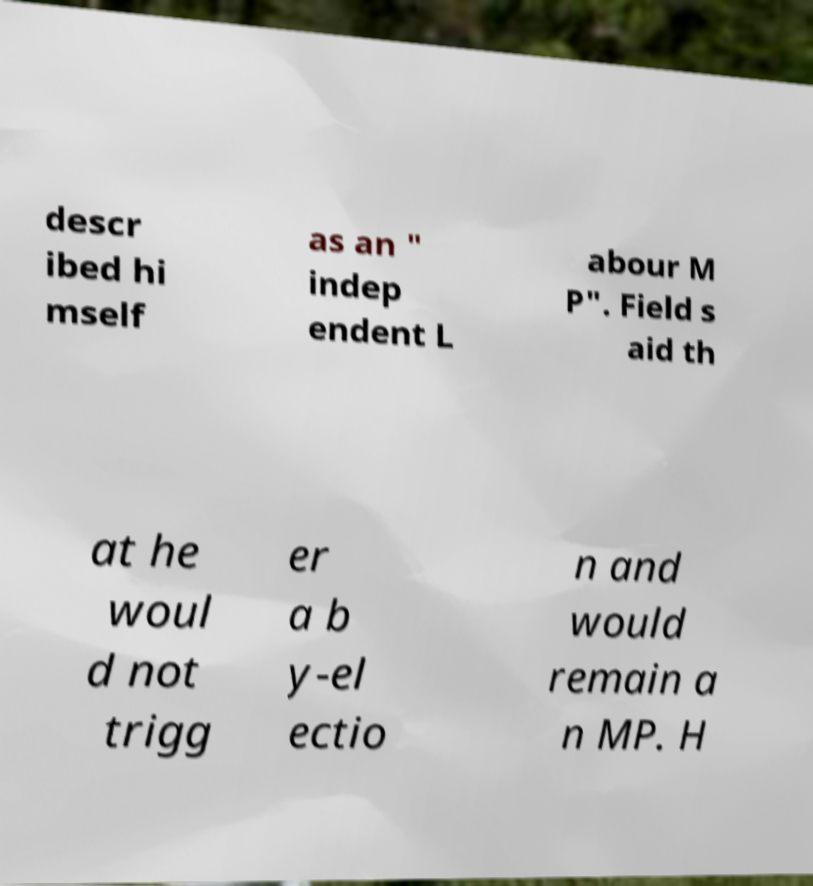Could you extract and type out the text from this image? descr ibed hi mself as an " indep endent L abour M P". Field s aid th at he woul d not trigg er a b y-el ectio n and would remain a n MP. H 